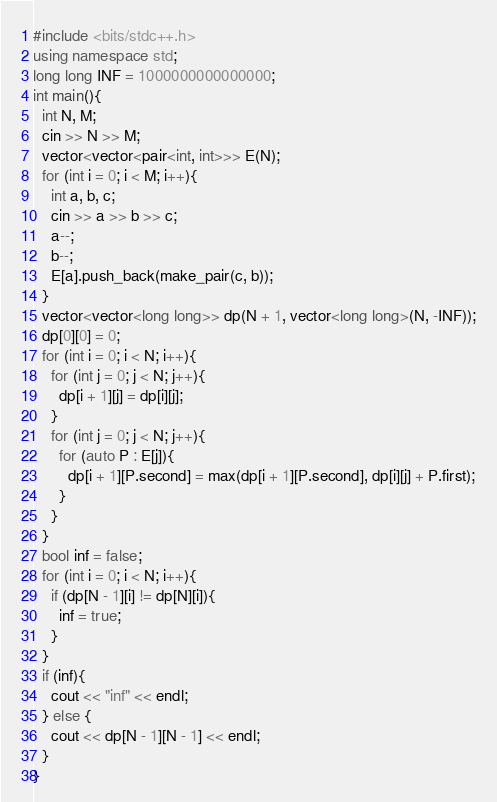Convert code to text. <code><loc_0><loc_0><loc_500><loc_500><_C++_>#include <bits/stdc++.h>
using namespace std;
long long INF = 1000000000000000;
int main(){
  int N, M;
  cin >> N >> M;
  vector<vector<pair<int, int>>> E(N);
  for (int i = 0; i < M; i++){
    int a, b, c;
    cin >> a >> b >> c;
    a--;
    b--;
    E[a].push_back(make_pair(c, b));
  }
  vector<vector<long long>> dp(N + 1, vector<long long>(N, -INF));
  dp[0][0] = 0;
  for (int i = 0; i < N; i++){
    for (int j = 0; j < N; j++){
      dp[i + 1][j] = dp[i][j];
    }
    for (int j = 0; j < N; j++){
      for (auto P : E[j]){
        dp[i + 1][P.second] = max(dp[i + 1][P.second], dp[i][j] + P.first);
      }
    }
  }
  bool inf = false;
  for (int i = 0; i < N; i++){
    if (dp[N - 1][i] != dp[N][i]){
      inf = true;
    }
  }
  if (inf){
    cout << "inf" << endl;
  } else {
    cout << dp[N - 1][N - 1] << endl;
  }
}</code> 